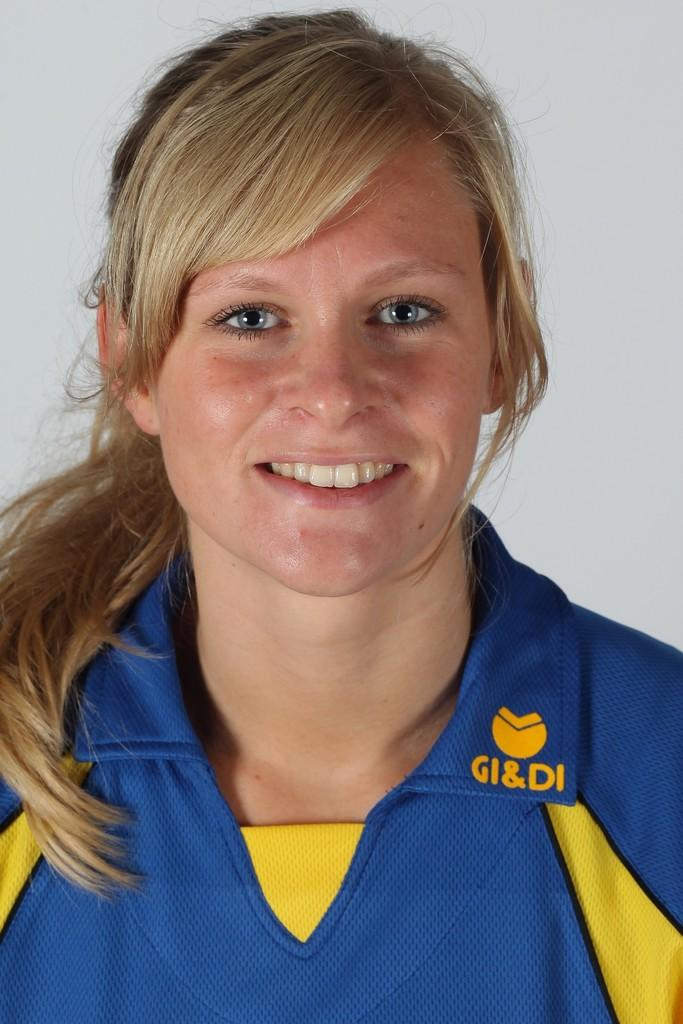<image>
Share a concise interpretation of the image provided. a woman wearing a shirt that says 'gi&di' on it 